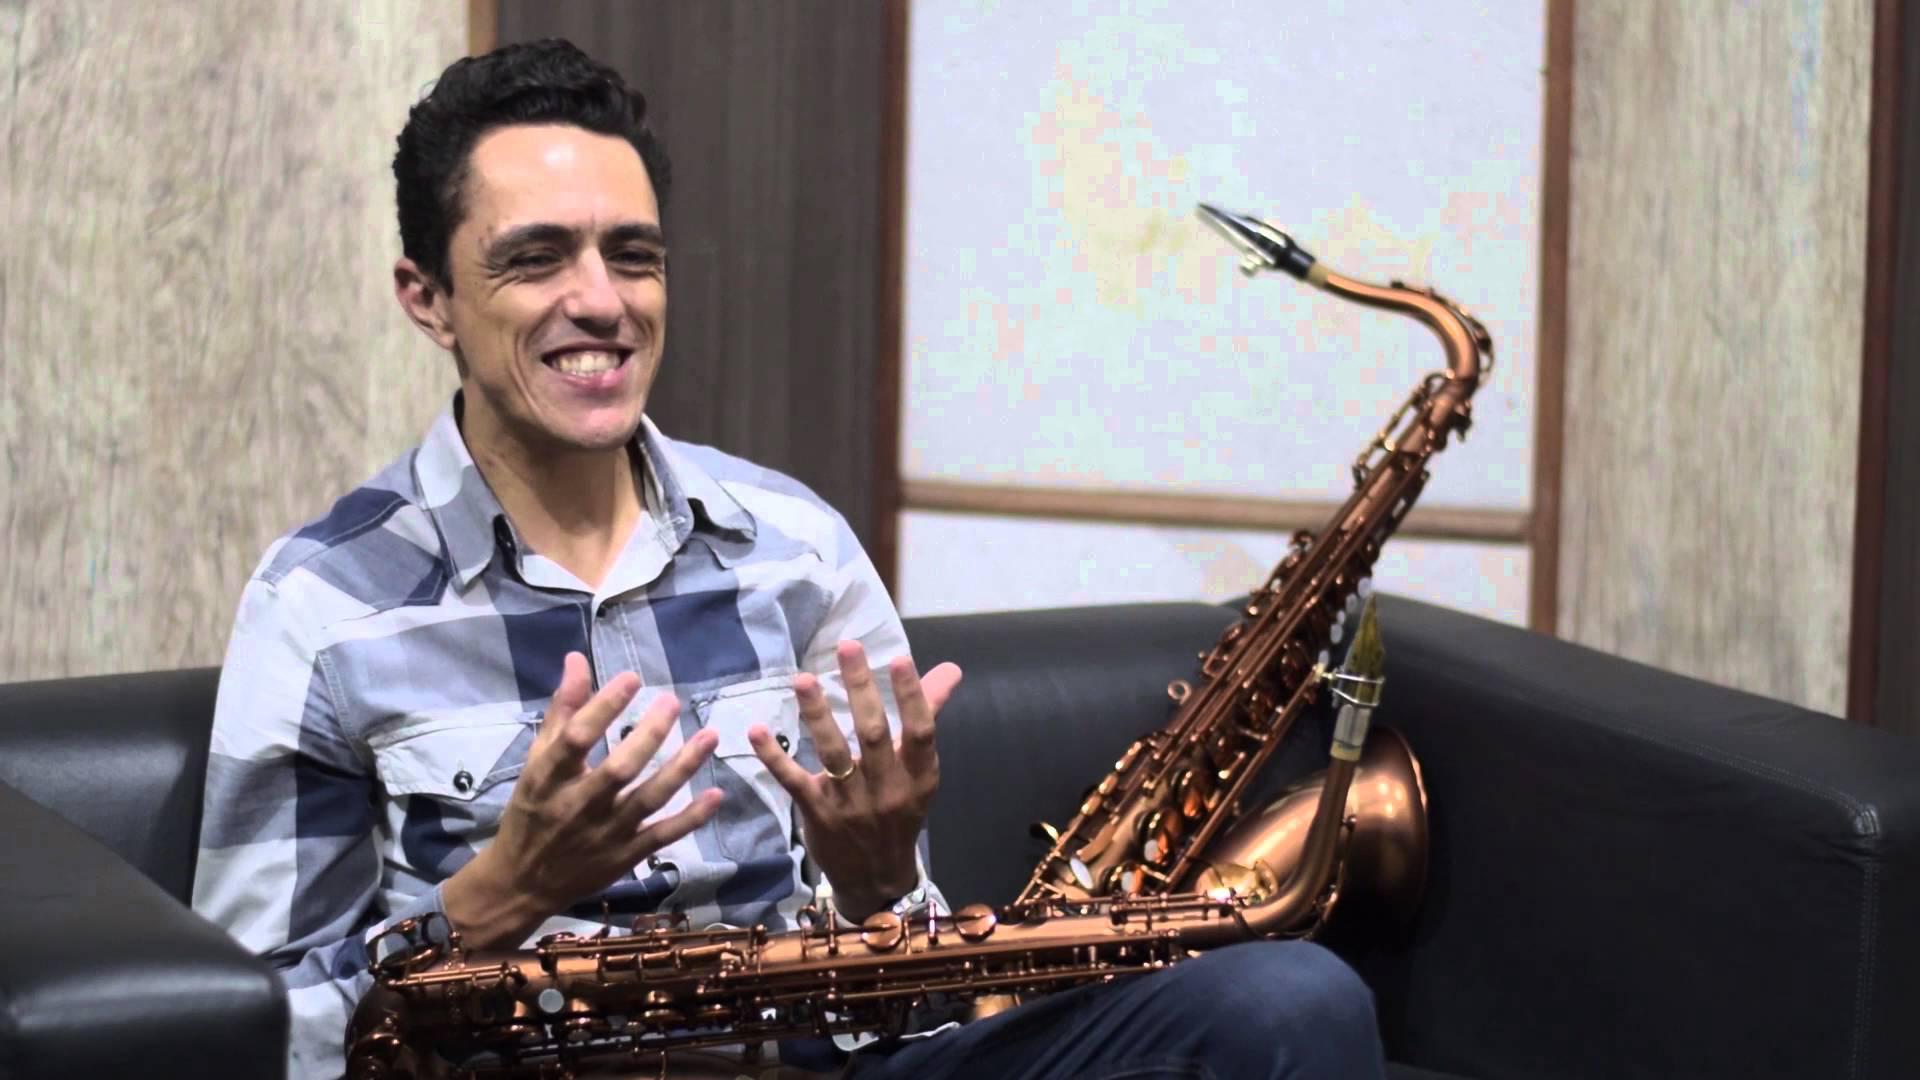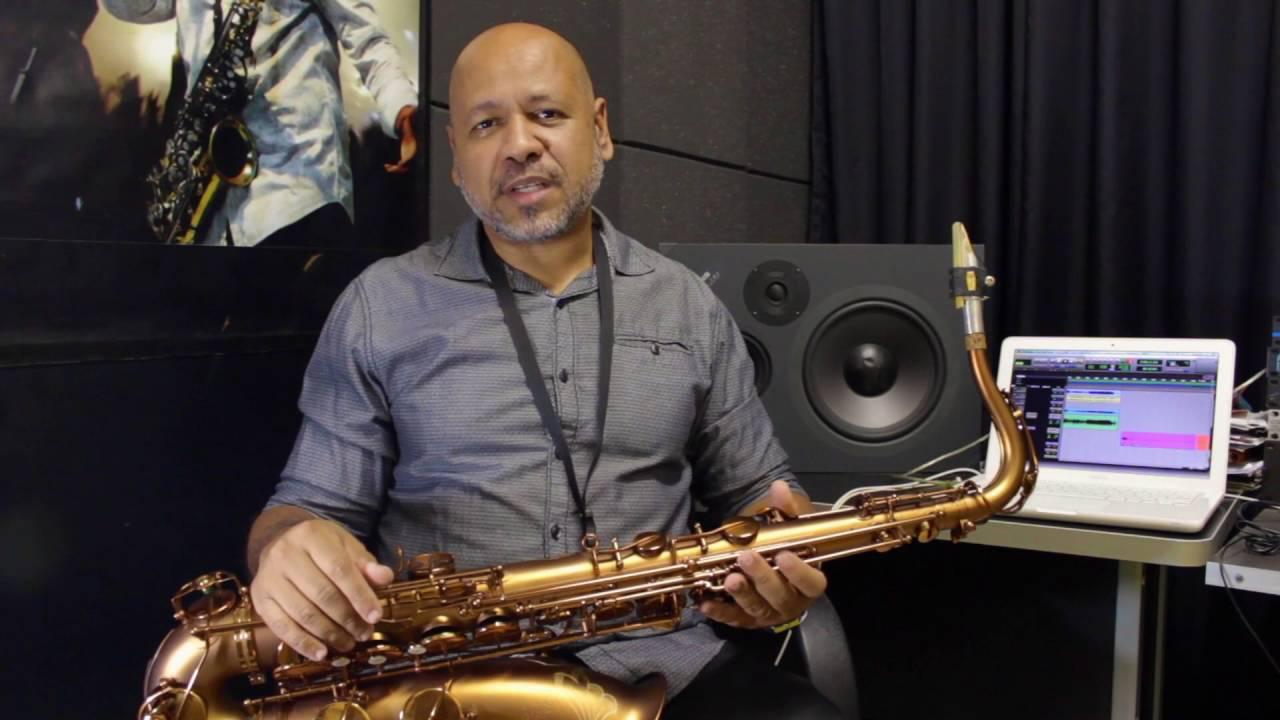The first image is the image on the left, the second image is the image on the right. For the images shown, is this caption "An image includes more than one saxophone." true? Answer yes or no. Yes. The first image is the image on the left, the second image is the image on the right. For the images shown, is this caption "Two saxophones with no musicians are lying down." true? Answer yes or no. No. 